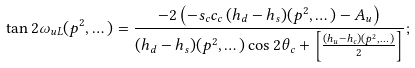Convert formula to latex. <formula><loc_0><loc_0><loc_500><loc_500>\tan 2 \omega _ { u L } ( p ^ { 2 } , \dots ) = \frac { - 2 \left ( - s _ { c } c _ { c } \, ( h _ { d } - h _ { s } ) ( p ^ { 2 } , \dots ) - A _ { u } \right ) } { ( h _ { d } - h _ { s } ) ( p ^ { 2 } , \dots ) \cos 2 \theta _ { c } + \left [ \frac { ( h _ { u } - h _ { c } ) ( p ^ { 2 } , \dots ) } { 2 } \right ] } ;</formula> 